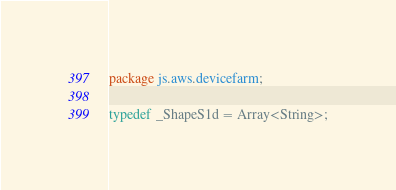Convert code to text. <code><loc_0><loc_0><loc_500><loc_500><_Haxe_>package js.aws.devicefarm;

typedef _ShapeS1d = Array<String>;
</code> 